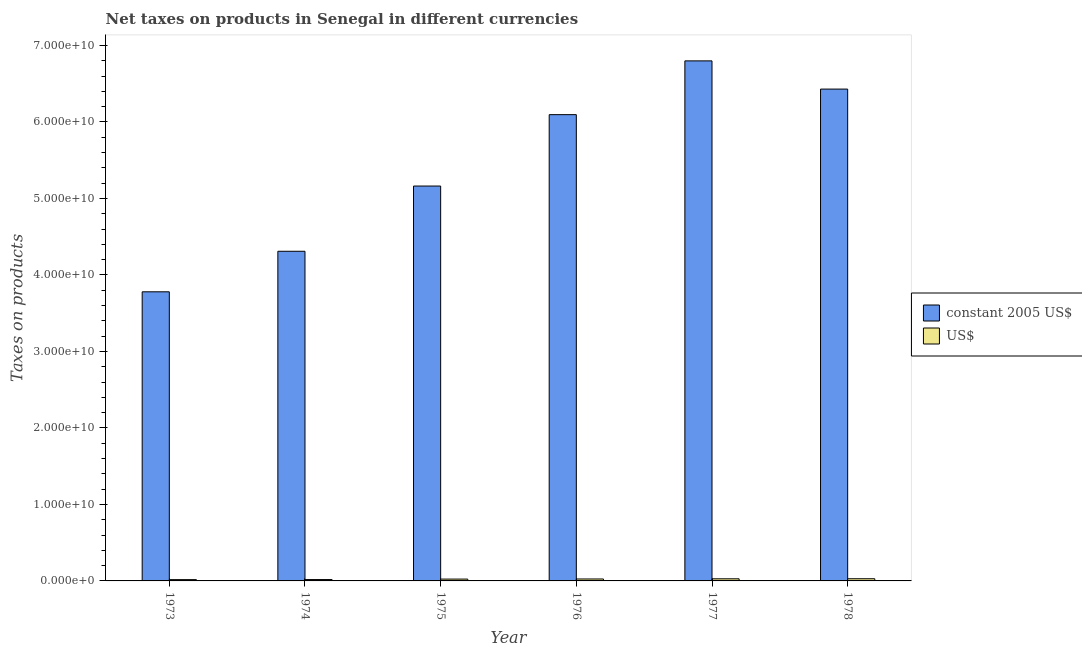How many groups of bars are there?
Provide a short and direct response. 6. How many bars are there on the 1st tick from the left?
Your response must be concise. 2. What is the label of the 5th group of bars from the left?
Keep it short and to the point. 1977. In how many cases, is the number of bars for a given year not equal to the number of legend labels?
Make the answer very short. 0. What is the net taxes in us$ in 1975?
Offer a terse response. 2.41e+08. Across all years, what is the maximum net taxes in constant 2005 us$?
Provide a succinct answer. 6.80e+1. Across all years, what is the minimum net taxes in us$?
Offer a terse response. 1.70e+08. What is the total net taxes in constant 2005 us$ in the graph?
Your answer should be very brief. 3.26e+11. What is the difference between the net taxes in us$ in 1976 and that in 1978?
Make the answer very short. -2.98e+07. What is the difference between the net taxes in us$ in 1975 and the net taxes in constant 2005 us$ in 1974?
Ensure brevity in your answer.  6.18e+07. What is the average net taxes in constant 2005 us$ per year?
Ensure brevity in your answer.  5.43e+1. In the year 1977, what is the difference between the net taxes in constant 2005 us$ and net taxes in us$?
Your response must be concise. 0. What is the ratio of the net taxes in us$ in 1975 to that in 1976?
Make the answer very short. 0.94. Is the net taxes in constant 2005 us$ in 1976 less than that in 1978?
Offer a very short reply. Yes. Is the difference between the net taxes in us$ in 1974 and 1978 greater than the difference between the net taxes in constant 2005 us$ in 1974 and 1978?
Ensure brevity in your answer.  No. What is the difference between the highest and the second highest net taxes in constant 2005 us$?
Give a very brief answer. 3.69e+09. What is the difference between the highest and the lowest net taxes in us$?
Offer a terse response. 1.15e+08. What does the 2nd bar from the left in 1977 represents?
Keep it short and to the point. US$. What does the 2nd bar from the right in 1973 represents?
Offer a terse response. Constant 2005 us$. What is the difference between two consecutive major ticks on the Y-axis?
Ensure brevity in your answer.  1.00e+1. Are the values on the major ticks of Y-axis written in scientific E-notation?
Offer a very short reply. Yes. Does the graph contain any zero values?
Make the answer very short. No. Does the graph contain grids?
Provide a succinct answer. No. How many legend labels are there?
Give a very brief answer. 2. What is the title of the graph?
Provide a succinct answer. Net taxes on products in Senegal in different currencies. What is the label or title of the Y-axis?
Offer a terse response. Taxes on products. What is the Taxes on products of constant 2005 US$ in 1973?
Your response must be concise. 3.78e+1. What is the Taxes on products in US$ in 1973?
Your answer should be very brief. 1.70e+08. What is the Taxes on products of constant 2005 US$ in 1974?
Your answer should be compact. 4.31e+1. What is the Taxes on products in US$ in 1974?
Keep it short and to the point. 1.79e+08. What is the Taxes on products in constant 2005 US$ in 1975?
Your answer should be very brief. 5.16e+1. What is the Taxes on products of US$ in 1975?
Your answer should be compact. 2.41e+08. What is the Taxes on products of constant 2005 US$ in 1976?
Provide a short and direct response. 6.10e+1. What is the Taxes on products of US$ in 1976?
Your answer should be compact. 2.55e+08. What is the Taxes on products of constant 2005 US$ in 1977?
Give a very brief answer. 6.80e+1. What is the Taxes on products of US$ in 1977?
Give a very brief answer. 2.77e+08. What is the Taxes on products of constant 2005 US$ in 1978?
Offer a terse response. 6.43e+1. What is the Taxes on products of US$ in 1978?
Keep it short and to the point. 2.85e+08. Across all years, what is the maximum Taxes on products in constant 2005 US$?
Provide a short and direct response. 6.80e+1. Across all years, what is the maximum Taxes on products in US$?
Your answer should be very brief. 2.85e+08. Across all years, what is the minimum Taxes on products in constant 2005 US$?
Make the answer very short. 3.78e+1. Across all years, what is the minimum Taxes on products in US$?
Give a very brief answer. 1.70e+08. What is the total Taxes on products in constant 2005 US$ in the graph?
Your response must be concise. 3.26e+11. What is the total Taxes on products of US$ in the graph?
Keep it short and to the point. 1.41e+09. What is the difference between the Taxes on products in constant 2005 US$ in 1973 and that in 1974?
Keep it short and to the point. -5.30e+09. What is the difference between the Taxes on products in US$ in 1973 and that in 1974?
Offer a terse response. -9.47e+06. What is the difference between the Taxes on products in constant 2005 US$ in 1973 and that in 1975?
Your response must be concise. -1.38e+1. What is the difference between the Taxes on products of US$ in 1973 and that in 1975?
Provide a short and direct response. -7.13e+07. What is the difference between the Taxes on products in constant 2005 US$ in 1973 and that in 1976?
Offer a terse response. -2.32e+1. What is the difference between the Taxes on products of US$ in 1973 and that in 1976?
Provide a short and direct response. -8.55e+07. What is the difference between the Taxes on products in constant 2005 US$ in 1973 and that in 1977?
Your response must be concise. -3.02e+1. What is the difference between the Taxes on products in US$ in 1973 and that in 1977?
Give a very brief answer. -1.07e+08. What is the difference between the Taxes on products of constant 2005 US$ in 1973 and that in 1978?
Keep it short and to the point. -2.65e+1. What is the difference between the Taxes on products in US$ in 1973 and that in 1978?
Offer a terse response. -1.15e+08. What is the difference between the Taxes on products of constant 2005 US$ in 1974 and that in 1975?
Keep it short and to the point. -8.53e+09. What is the difference between the Taxes on products in US$ in 1974 and that in 1975?
Offer a very short reply. -6.18e+07. What is the difference between the Taxes on products of constant 2005 US$ in 1974 and that in 1976?
Keep it short and to the point. -1.79e+1. What is the difference between the Taxes on products of US$ in 1974 and that in 1976?
Your response must be concise. -7.61e+07. What is the difference between the Taxes on products of constant 2005 US$ in 1974 and that in 1977?
Offer a very short reply. -2.49e+1. What is the difference between the Taxes on products in US$ in 1974 and that in 1977?
Offer a terse response. -9.77e+07. What is the difference between the Taxes on products in constant 2005 US$ in 1974 and that in 1978?
Provide a succinct answer. -2.12e+1. What is the difference between the Taxes on products in US$ in 1974 and that in 1978?
Your answer should be compact. -1.06e+08. What is the difference between the Taxes on products in constant 2005 US$ in 1975 and that in 1976?
Offer a terse response. -9.33e+09. What is the difference between the Taxes on products in US$ in 1975 and that in 1976?
Offer a terse response. -1.42e+07. What is the difference between the Taxes on products in constant 2005 US$ in 1975 and that in 1977?
Keep it short and to the point. -1.64e+1. What is the difference between the Taxes on products of US$ in 1975 and that in 1977?
Ensure brevity in your answer.  -3.58e+07. What is the difference between the Taxes on products of constant 2005 US$ in 1975 and that in 1978?
Make the answer very short. -1.27e+1. What is the difference between the Taxes on products in US$ in 1975 and that in 1978?
Offer a terse response. -4.41e+07. What is the difference between the Taxes on products in constant 2005 US$ in 1976 and that in 1977?
Offer a very short reply. -7.03e+09. What is the difference between the Taxes on products of US$ in 1976 and that in 1977?
Make the answer very short. -2.16e+07. What is the difference between the Taxes on products of constant 2005 US$ in 1976 and that in 1978?
Your answer should be very brief. -3.34e+09. What is the difference between the Taxes on products of US$ in 1976 and that in 1978?
Your answer should be very brief. -2.98e+07. What is the difference between the Taxes on products of constant 2005 US$ in 1977 and that in 1978?
Ensure brevity in your answer.  3.69e+09. What is the difference between the Taxes on products in US$ in 1977 and that in 1978?
Provide a succinct answer. -8.21e+06. What is the difference between the Taxes on products of constant 2005 US$ in 1973 and the Taxes on products of US$ in 1974?
Make the answer very short. 3.76e+1. What is the difference between the Taxes on products of constant 2005 US$ in 1973 and the Taxes on products of US$ in 1975?
Your answer should be compact. 3.76e+1. What is the difference between the Taxes on products of constant 2005 US$ in 1973 and the Taxes on products of US$ in 1976?
Your answer should be very brief. 3.75e+1. What is the difference between the Taxes on products in constant 2005 US$ in 1973 and the Taxes on products in US$ in 1977?
Your answer should be compact. 3.75e+1. What is the difference between the Taxes on products in constant 2005 US$ in 1973 and the Taxes on products in US$ in 1978?
Keep it short and to the point. 3.75e+1. What is the difference between the Taxes on products in constant 2005 US$ in 1974 and the Taxes on products in US$ in 1975?
Keep it short and to the point. 4.29e+1. What is the difference between the Taxes on products of constant 2005 US$ in 1974 and the Taxes on products of US$ in 1976?
Provide a short and direct response. 4.28e+1. What is the difference between the Taxes on products of constant 2005 US$ in 1974 and the Taxes on products of US$ in 1977?
Provide a short and direct response. 4.28e+1. What is the difference between the Taxes on products of constant 2005 US$ in 1974 and the Taxes on products of US$ in 1978?
Your answer should be compact. 4.28e+1. What is the difference between the Taxes on products in constant 2005 US$ in 1975 and the Taxes on products in US$ in 1976?
Provide a succinct answer. 5.14e+1. What is the difference between the Taxes on products in constant 2005 US$ in 1975 and the Taxes on products in US$ in 1977?
Provide a short and direct response. 5.13e+1. What is the difference between the Taxes on products in constant 2005 US$ in 1975 and the Taxes on products in US$ in 1978?
Provide a short and direct response. 5.13e+1. What is the difference between the Taxes on products in constant 2005 US$ in 1976 and the Taxes on products in US$ in 1977?
Offer a very short reply. 6.07e+1. What is the difference between the Taxes on products in constant 2005 US$ in 1976 and the Taxes on products in US$ in 1978?
Offer a very short reply. 6.07e+1. What is the difference between the Taxes on products in constant 2005 US$ in 1977 and the Taxes on products in US$ in 1978?
Your response must be concise. 6.77e+1. What is the average Taxes on products in constant 2005 US$ per year?
Provide a succinct answer. 5.43e+1. What is the average Taxes on products of US$ per year?
Provide a succinct answer. 2.34e+08. In the year 1973, what is the difference between the Taxes on products of constant 2005 US$ and Taxes on products of US$?
Provide a short and direct response. 3.76e+1. In the year 1974, what is the difference between the Taxes on products in constant 2005 US$ and Taxes on products in US$?
Offer a very short reply. 4.29e+1. In the year 1975, what is the difference between the Taxes on products in constant 2005 US$ and Taxes on products in US$?
Your answer should be compact. 5.14e+1. In the year 1976, what is the difference between the Taxes on products in constant 2005 US$ and Taxes on products in US$?
Your answer should be very brief. 6.07e+1. In the year 1977, what is the difference between the Taxes on products in constant 2005 US$ and Taxes on products in US$?
Your response must be concise. 6.77e+1. In the year 1978, what is the difference between the Taxes on products in constant 2005 US$ and Taxes on products in US$?
Provide a succinct answer. 6.40e+1. What is the ratio of the Taxes on products in constant 2005 US$ in 1973 to that in 1974?
Your answer should be very brief. 0.88. What is the ratio of the Taxes on products of US$ in 1973 to that in 1974?
Offer a very short reply. 0.95. What is the ratio of the Taxes on products in constant 2005 US$ in 1973 to that in 1975?
Make the answer very short. 0.73. What is the ratio of the Taxes on products in US$ in 1973 to that in 1975?
Give a very brief answer. 0.7. What is the ratio of the Taxes on products of constant 2005 US$ in 1973 to that in 1976?
Your answer should be compact. 0.62. What is the ratio of the Taxes on products in US$ in 1973 to that in 1976?
Offer a terse response. 0.66. What is the ratio of the Taxes on products of constant 2005 US$ in 1973 to that in 1977?
Provide a short and direct response. 0.56. What is the ratio of the Taxes on products of US$ in 1973 to that in 1977?
Your response must be concise. 0.61. What is the ratio of the Taxes on products in constant 2005 US$ in 1973 to that in 1978?
Ensure brevity in your answer.  0.59. What is the ratio of the Taxes on products in US$ in 1973 to that in 1978?
Your answer should be compact. 0.6. What is the ratio of the Taxes on products in constant 2005 US$ in 1974 to that in 1975?
Provide a succinct answer. 0.83. What is the ratio of the Taxes on products of US$ in 1974 to that in 1975?
Provide a succinct answer. 0.74. What is the ratio of the Taxes on products of constant 2005 US$ in 1974 to that in 1976?
Your answer should be compact. 0.71. What is the ratio of the Taxes on products in US$ in 1974 to that in 1976?
Offer a terse response. 0.7. What is the ratio of the Taxes on products of constant 2005 US$ in 1974 to that in 1977?
Make the answer very short. 0.63. What is the ratio of the Taxes on products in US$ in 1974 to that in 1977?
Keep it short and to the point. 0.65. What is the ratio of the Taxes on products of constant 2005 US$ in 1974 to that in 1978?
Give a very brief answer. 0.67. What is the ratio of the Taxes on products in US$ in 1974 to that in 1978?
Your answer should be very brief. 0.63. What is the ratio of the Taxes on products in constant 2005 US$ in 1975 to that in 1976?
Offer a very short reply. 0.85. What is the ratio of the Taxes on products in US$ in 1975 to that in 1976?
Ensure brevity in your answer.  0.94. What is the ratio of the Taxes on products of constant 2005 US$ in 1975 to that in 1977?
Your answer should be compact. 0.76. What is the ratio of the Taxes on products in US$ in 1975 to that in 1977?
Your response must be concise. 0.87. What is the ratio of the Taxes on products in constant 2005 US$ in 1975 to that in 1978?
Your answer should be very brief. 0.8. What is the ratio of the Taxes on products of US$ in 1975 to that in 1978?
Your answer should be very brief. 0.85. What is the ratio of the Taxes on products of constant 2005 US$ in 1976 to that in 1977?
Your answer should be compact. 0.9. What is the ratio of the Taxes on products of US$ in 1976 to that in 1977?
Your response must be concise. 0.92. What is the ratio of the Taxes on products of constant 2005 US$ in 1976 to that in 1978?
Offer a very short reply. 0.95. What is the ratio of the Taxes on products of US$ in 1976 to that in 1978?
Your response must be concise. 0.9. What is the ratio of the Taxes on products of constant 2005 US$ in 1977 to that in 1978?
Provide a succinct answer. 1.06. What is the ratio of the Taxes on products of US$ in 1977 to that in 1978?
Your response must be concise. 0.97. What is the difference between the highest and the second highest Taxes on products of constant 2005 US$?
Provide a succinct answer. 3.69e+09. What is the difference between the highest and the second highest Taxes on products of US$?
Your answer should be very brief. 8.21e+06. What is the difference between the highest and the lowest Taxes on products in constant 2005 US$?
Make the answer very short. 3.02e+1. What is the difference between the highest and the lowest Taxes on products in US$?
Make the answer very short. 1.15e+08. 